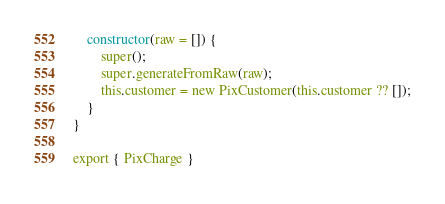<code> <loc_0><loc_0><loc_500><loc_500><_JavaScript_>
    constructor(raw = []) {
        super();
        super.generateFromRaw(raw);
        this.customer = new PixCustomer(this.customer ?? []);
    }
}

export { PixCharge }</code> 